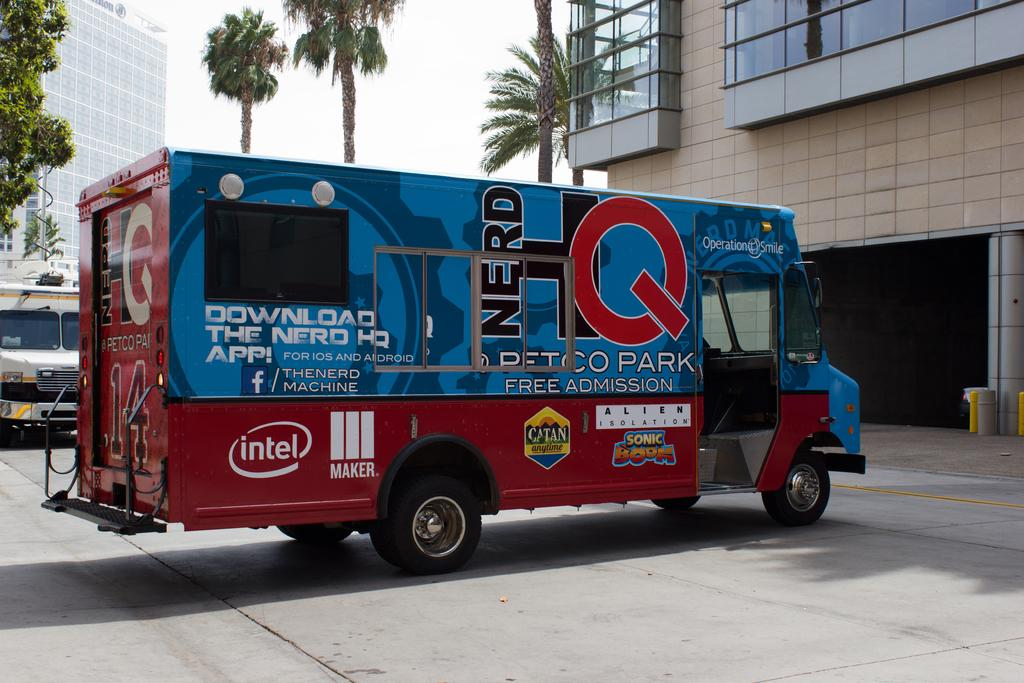What is parked on the road in the image? There is a vehicle parked on the road in the image. What can be seen in the background of the image? In the background, there are buildings, walls, glass objects, trees, another vehicle, pillars, and the sky. Can you describe the other vehicle in the background? There is another vehicle in the background, but its specific details cannot be determined from the image. What type of collar can be seen on the vehicle in the image? There is no collar present on the vehicle in the image. What songs are being played by the trees in the background? The trees in the background are not playing any songs; they are simply trees. 